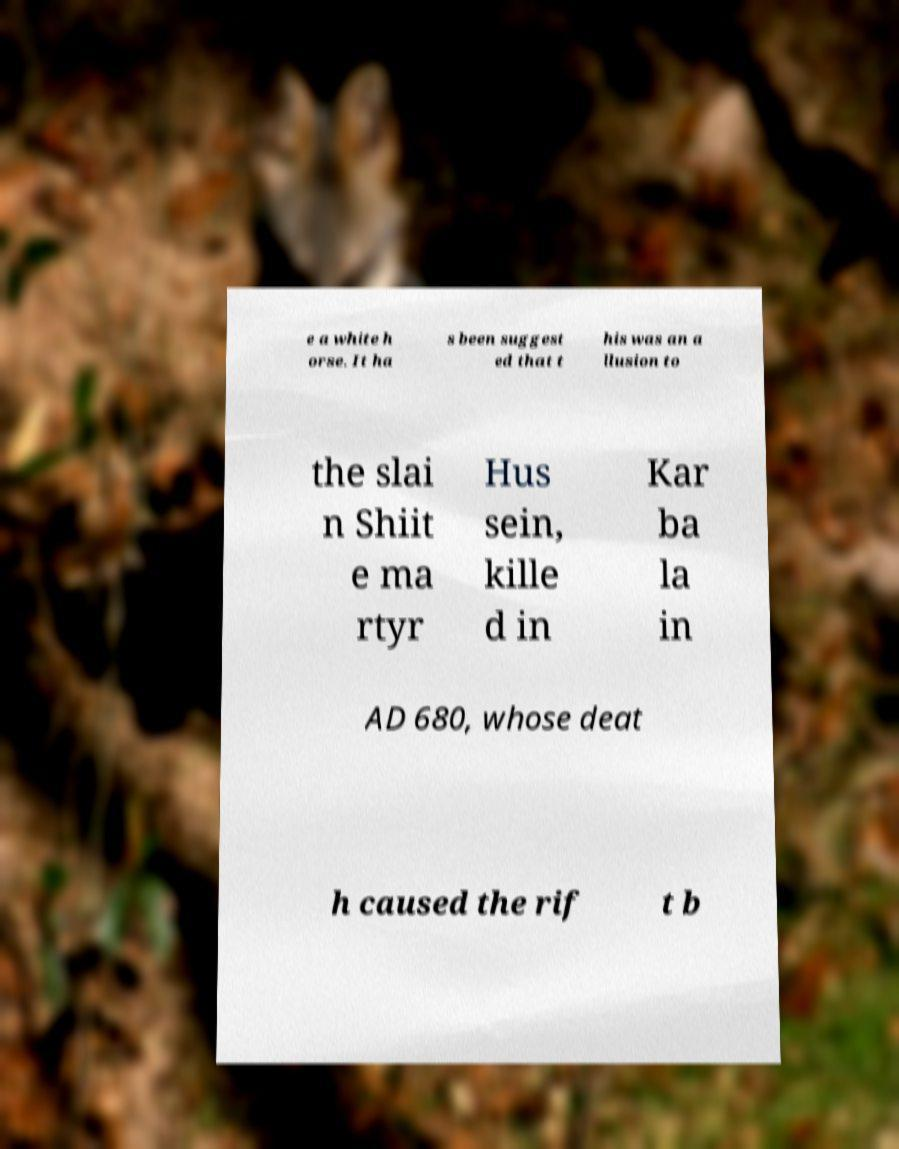What messages or text are displayed in this image? I need them in a readable, typed format. e a white h orse. It ha s been suggest ed that t his was an a llusion to the slai n Shiit e ma rtyr Hus sein, kille d in Kar ba la in AD 680, whose deat h caused the rif t b 